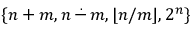Convert formula to latex. <formula><loc_0><loc_0><loc_500><loc_500>\{ n + m , n \, { \stackrel { . } { - } } \, m , \lfloor n / m \rfloor , 2 ^ { n } \}</formula> 